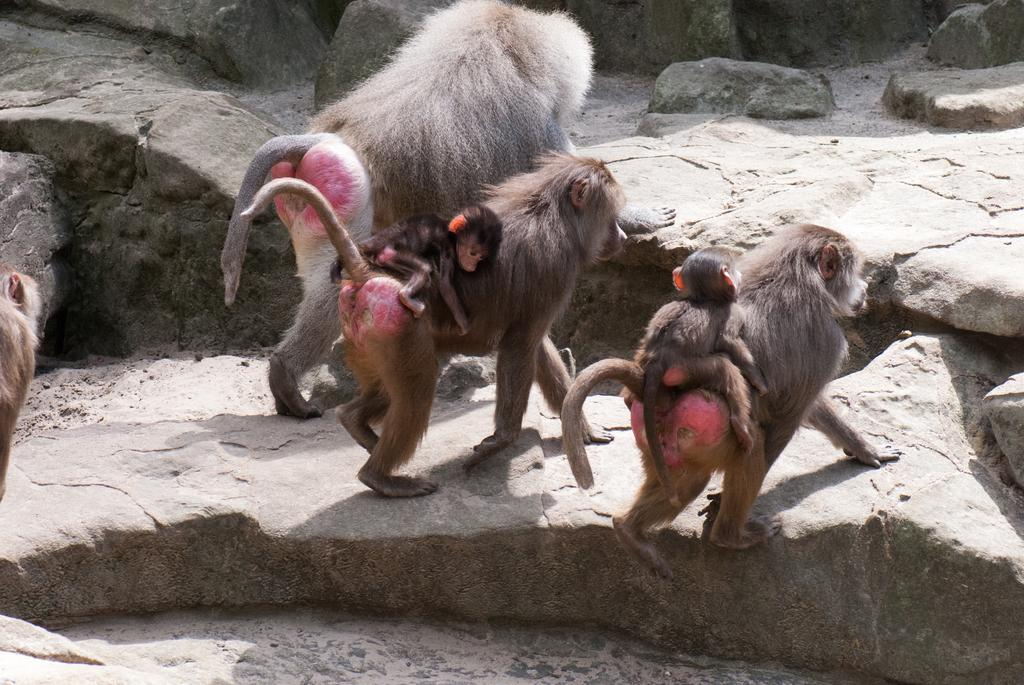What animals are present in the image? There are monkeys in the image. Are the monkeys performing any actions or carrying anything? Yes, two monkeys are carrying baby monkeys. What is the surface on which the monkeys are standing? The monkeys are on a rock floor. What route does the boy take to reach the park in the image? There is no boy or park present in the image; it features monkeys on a rock floor. 